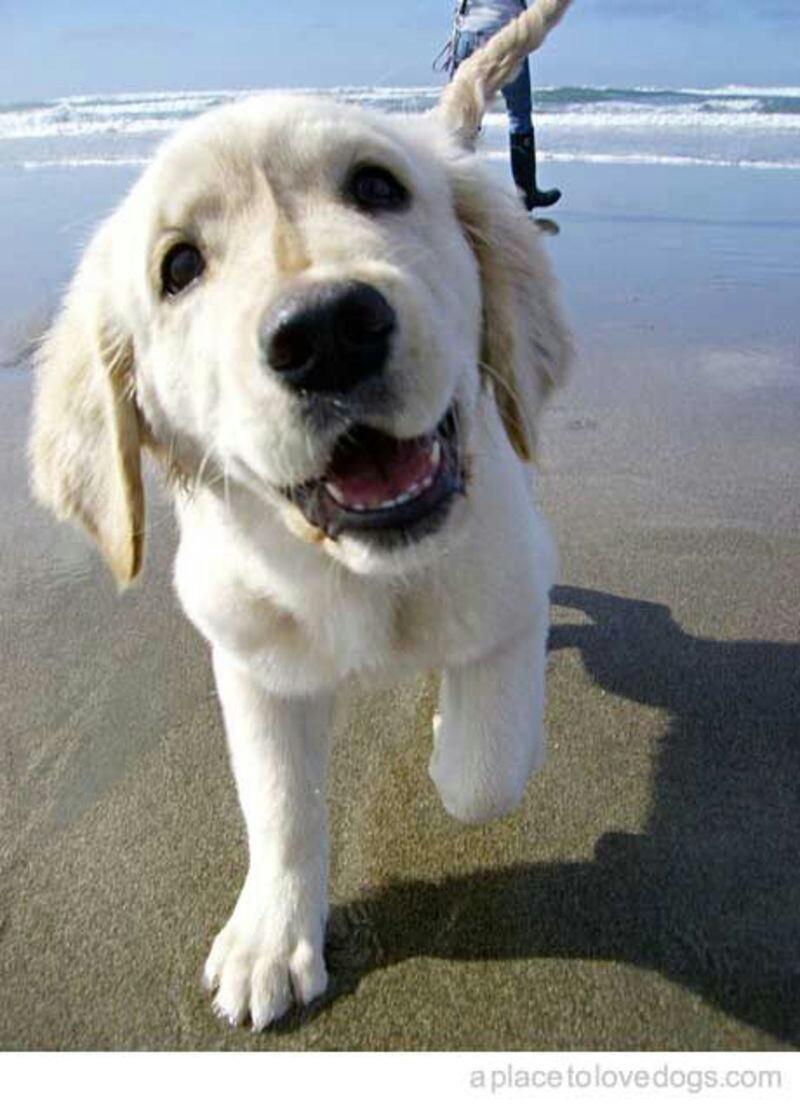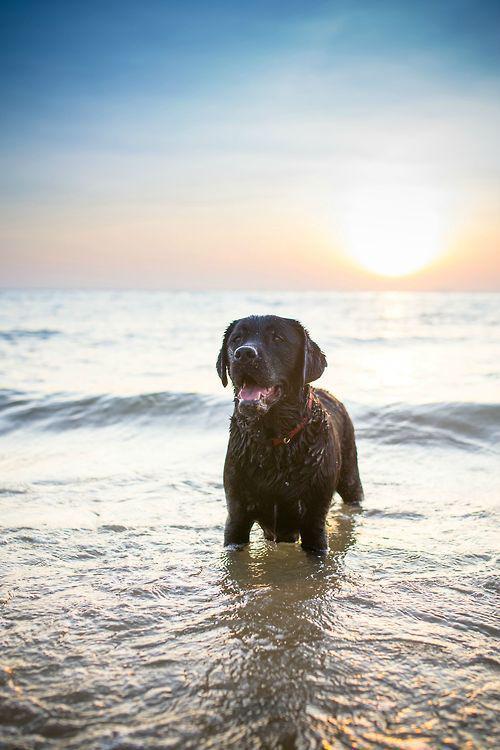The first image is the image on the left, the second image is the image on the right. Analyze the images presented: Is the assertion "One of the images features a dog standing in liquid water." valid? Answer yes or no. Yes. The first image is the image on the left, the second image is the image on the right. Considering the images on both sides, is "There are no more than two animals." valid? Answer yes or no. Yes. 